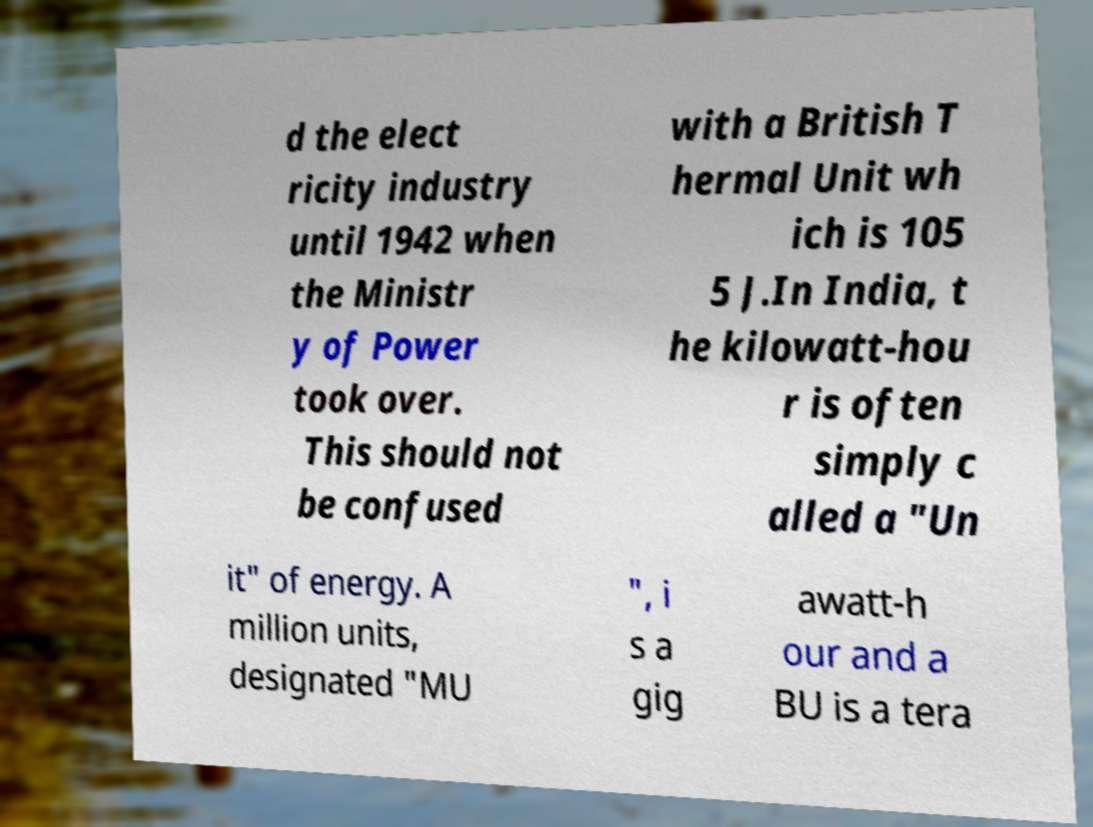Can you accurately transcribe the text from the provided image for me? d the elect ricity industry until 1942 when the Ministr y of Power took over. This should not be confused with a British T hermal Unit wh ich is 105 5 J.In India, t he kilowatt-hou r is often simply c alled a "Un it" of energy. A million units, designated "MU ", i s a gig awatt-h our and a BU is a tera 